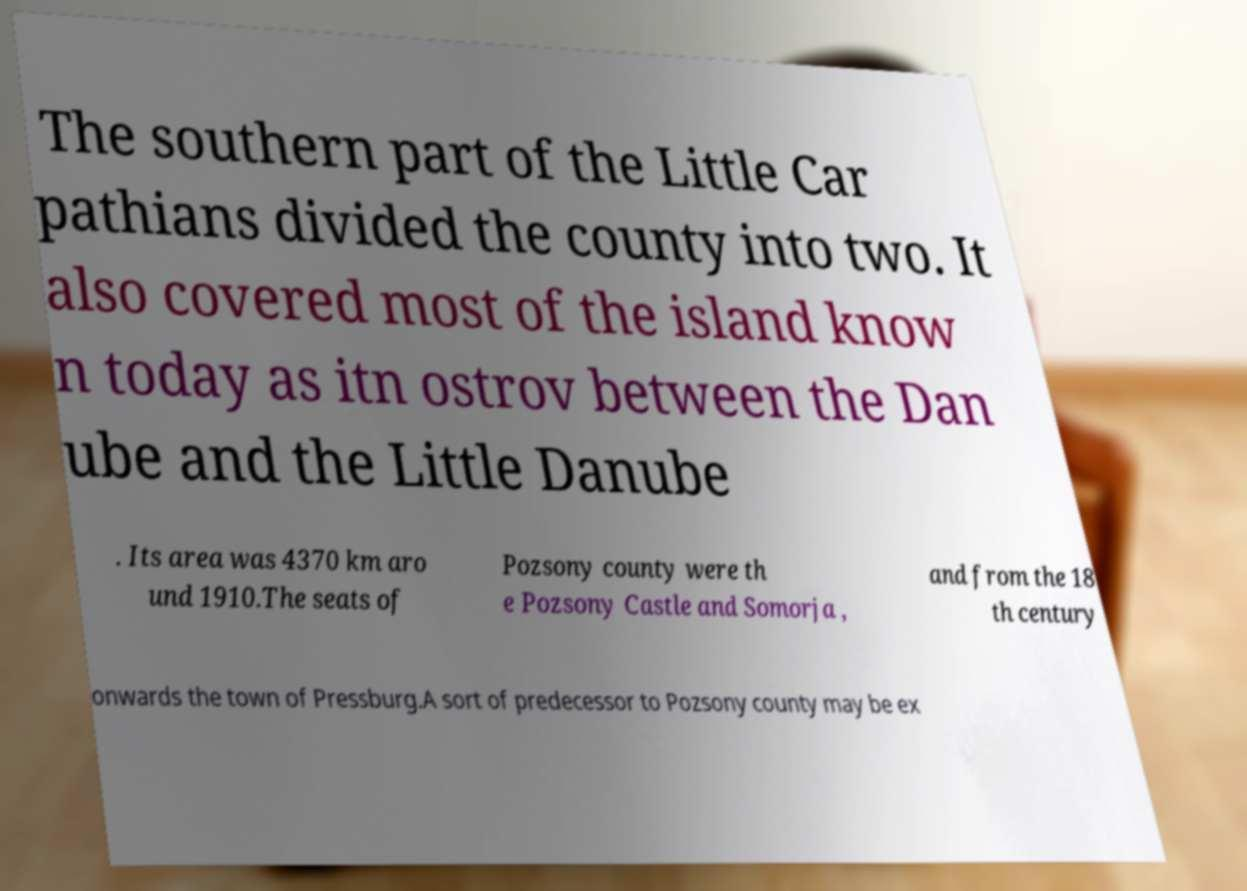Please read and relay the text visible in this image. What does it say? The southern part of the Little Car pathians divided the county into two. It also covered most of the island know n today as itn ostrov between the Dan ube and the Little Danube . Its area was 4370 km aro und 1910.The seats of Pozsony county were th e Pozsony Castle and Somorja , and from the 18 th century onwards the town of Pressburg.A sort of predecessor to Pozsony county may be ex 